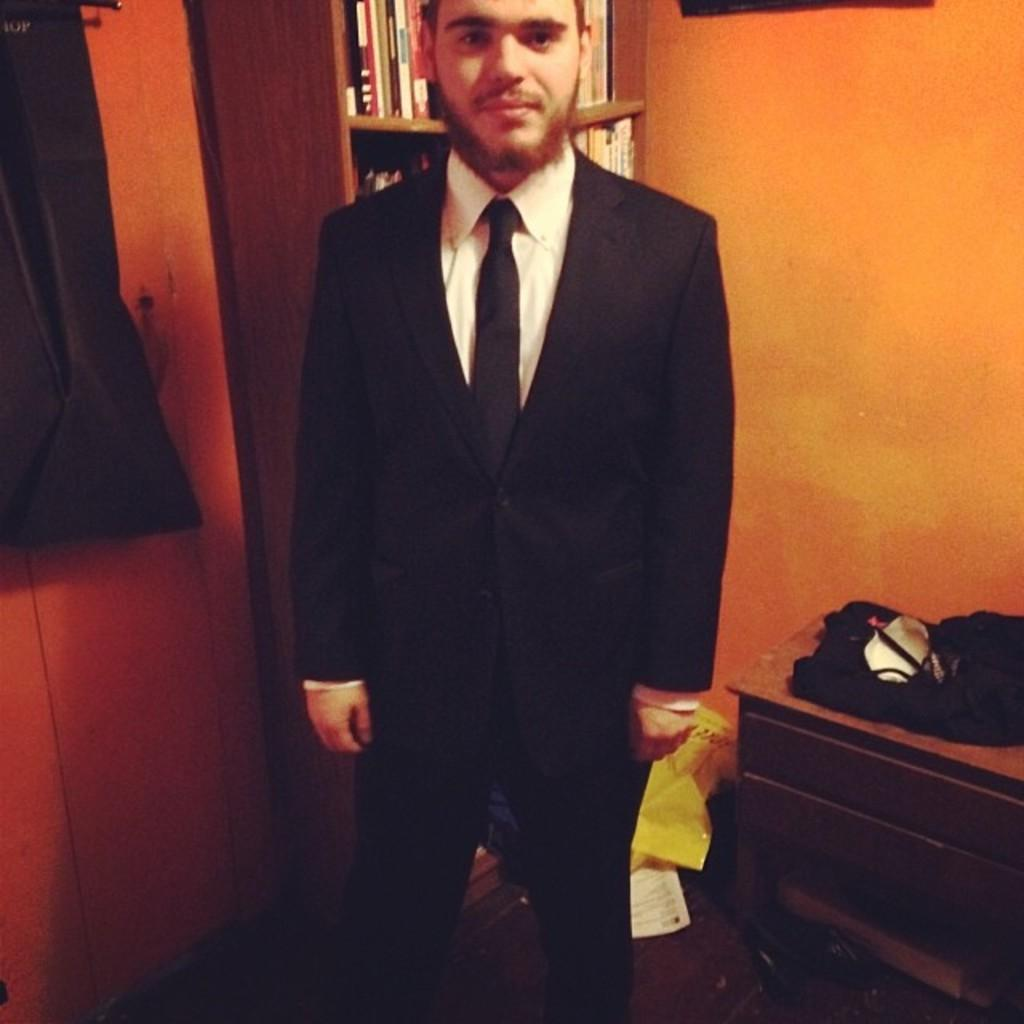What is the main subject in the image? There is a man standing in the image. What can be seen on the wall in the background? There is a wall in the background of the image. What type of furniture is visible in the image? There are books in a bookshelf in the image. What other objects can be seen in the image besides the man and bookshelf? There are other objects in the image. How many snakes are crawling on the man in the image? There are no snakes present in the image; the man is standing alone. What type of maid is attending to the man in the image? There is no maid present in the image; the man is standing alone. 